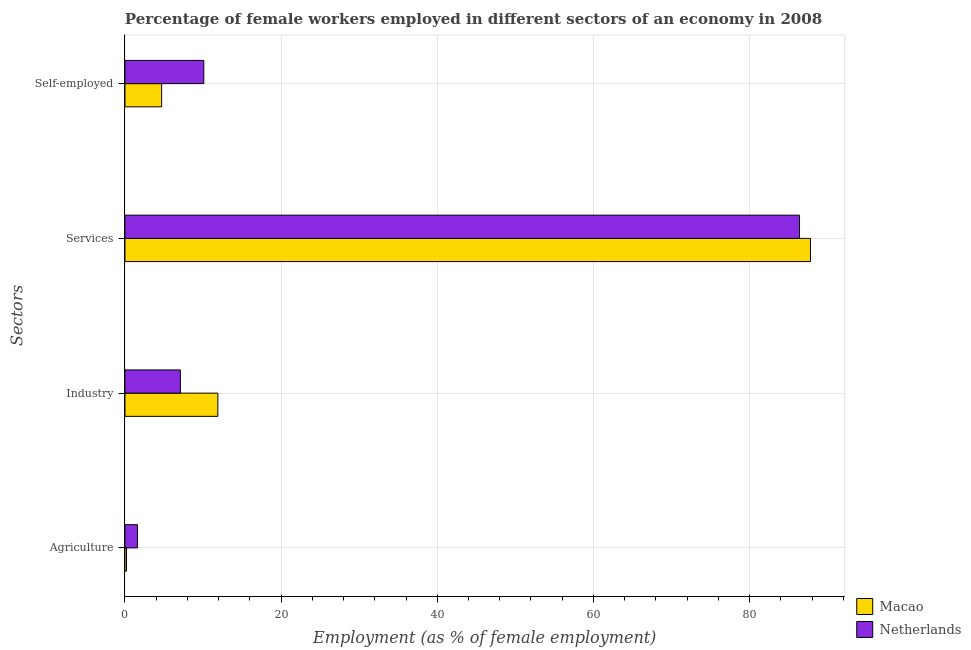Are the number of bars per tick equal to the number of legend labels?
Make the answer very short. Yes. Are the number of bars on each tick of the Y-axis equal?
Keep it short and to the point. Yes. What is the label of the 4th group of bars from the top?
Offer a terse response. Agriculture. What is the percentage of female workers in agriculture in Netherlands?
Ensure brevity in your answer.  1.6. Across all countries, what is the maximum percentage of female workers in agriculture?
Your response must be concise. 1.6. Across all countries, what is the minimum percentage of self employed female workers?
Provide a short and direct response. 4.7. In which country was the percentage of female workers in industry maximum?
Offer a very short reply. Macao. In which country was the percentage of female workers in services minimum?
Give a very brief answer. Netherlands. What is the total percentage of female workers in services in the graph?
Your response must be concise. 174.2. What is the difference between the percentage of female workers in industry in Netherlands and that in Macao?
Offer a terse response. -4.8. What is the difference between the percentage of female workers in agriculture in Macao and the percentage of self employed female workers in Netherlands?
Keep it short and to the point. -9.9. What is the average percentage of female workers in agriculture per country?
Give a very brief answer. 0.9. What is the difference between the percentage of self employed female workers and percentage of female workers in agriculture in Macao?
Make the answer very short. 4.5. What is the ratio of the percentage of self employed female workers in Netherlands to that in Macao?
Provide a short and direct response. 2.15. Is the percentage of female workers in services in Netherlands less than that in Macao?
Your answer should be very brief. Yes. Is the difference between the percentage of female workers in services in Macao and Netherlands greater than the difference between the percentage of female workers in industry in Macao and Netherlands?
Give a very brief answer. No. What is the difference between the highest and the second highest percentage of female workers in services?
Provide a short and direct response. 1.4. What is the difference between the highest and the lowest percentage of female workers in services?
Provide a succinct answer. 1.4. Is it the case that in every country, the sum of the percentage of female workers in services and percentage of female workers in industry is greater than the sum of percentage of self employed female workers and percentage of female workers in agriculture?
Your answer should be very brief. Yes. Is it the case that in every country, the sum of the percentage of female workers in agriculture and percentage of female workers in industry is greater than the percentage of female workers in services?
Provide a succinct answer. No. How many bars are there?
Offer a very short reply. 8. Are all the bars in the graph horizontal?
Give a very brief answer. Yes. How many countries are there in the graph?
Provide a short and direct response. 2. Does the graph contain any zero values?
Your answer should be very brief. No. How many legend labels are there?
Your answer should be compact. 2. What is the title of the graph?
Your answer should be very brief. Percentage of female workers employed in different sectors of an economy in 2008. What is the label or title of the X-axis?
Your response must be concise. Employment (as % of female employment). What is the label or title of the Y-axis?
Your answer should be very brief. Sectors. What is the Employment (as % of female employment) of Macao in Agriculture?
Your answer should be compact. 0.2. What is the Employment (as % of female employment) in Netherlands in Agriculture?
Ensure brevity in your answer.  1.6. What is the Employment (as % of female employment) in Macao in Industry?
Your response must be concise. 11.9. What is the Employment (as % of female employment) in Netherlands in Industry?
Ensure brevity in your answer.  7.1. What is the Employment (as % of female employment) in Macao in Services?
Provide a succinct answer. 87.8. What is the Employment (as % of female employment) in Netherlands in Services?
Your response must be concise. 86.4. What is the Employment (as % of female employment) in Macao in Self-employed?
Keep it short and to the point. 4.7. What is the Employment (as % of female employment) of Netherlands in Self-employed?
Make the answer very short. 10.1. Across all Sectors, what is the maximum Employment (as % of female employment) in Macao?
Make the answer very short. 87.8. Across all Sectors, what is the maximum Employment (as % of female employment) of Netherlands?
Provide a succinct answer. 86.4. Across all Sectors, what is the minimum Employment (as % of female employment) in Macao?
Offer a very short reply. 0.2. Across all Sectors, what is the minimum Employment (as % of female employment) in Netherlands?
Offer a terse response. 1.6. What is the total Employment (as % of female employment) in Macao in the graph?
Your answer should be compact. 104.6. What is the total Employment (as % of female employment) in Netherlands in the graph?
Offer a very short reply. 105.2. What is the difference between the Employment (as % of female employment) of Macao in Agriculture and that in Industry?
Provide a short and direct response. -11.7. What is the difference between the Employment (as % of female employment) of Netherlands in Agriculture and that in Industry?
Provide a short and direct response. -5.5. What is the difference between the Employment (as % of female employment) of Macao in Agriculture and that in Services?
Your answer should be very brief. -87.6. What is the difference between the Employment (as % of female employment) of Netherlands in Agriculture and that in Services?
Keep it short and to the point. -84.8. What is the difference between the Employment (as % of female employment) of Macao in Agriculture and that in Self-employed?
Keep it short and to the point. -4.5. What is the difference between the Employment (as % of female employment) in Netherlands in Agriculture and that in Self-employed?
Keep it short and to the point. -8.5. What is the difference between the Employment (as % of female employment) in Macao in Industry and that in Services?
Offer a terse response. -75.9. What is the difference between the Employment (as % of female employment) of Netherlands in Industry and that in Services?
Provide a short and direct response. -79.3. What is the difference between the Employment (as % of female employment) of Macao in Industry and that in Self-employed?
Provide a succinct answer. 7.2. What is the difference between the Employment (as % of female employment) in Netherlands in Industry and that in Self-employed?
Your answer should be very brief. -3. What is the difference between the Employment (as % of female employment) of Macao in Services and that in Self-employed?
Keep it short and to the point. 83.1. What is the difference between the Employment (as % of female employment) of Netherlands in Services and that in Self-employed?
Offer a very short reply. 76.3. What is the difference between the Employment (as % of female employment) of Macao in Agriculture and the Employment (as % of female employment) of Netherlands in Industry?
Keep it short and to the point. -6.9. What is the difference between the Employment (as % of female employment) of Macao in Agriculture and the Employment (as % of female employment) of Netherlands in Services?
Make the answer very short. -86.2. What is the difference between the Employment (as % of female employment) of Macao in Agriculture and the Employment (as % of female employment) of Netherlands in Self-employed?
Offer a very short reply. -9.9. What is the difference between the Employment (as % of female employment) of Macao in Industry and the Employment (as % of female employment) of Netherlands in Services?
Your response must be concise. -74.5. What is the difference between the Employment (as % of female employment) of Macao in Services and the Employment (as % of female employment) of Netherlands in Self-employed?
Offer a very short reply. 77.7. What is the average Employment (as % of female employment) of Macao per Sectors?
Offer a terse response. 26.15. What is the average Employment (as % of female employment) of Netherlands per Sectors?
Offer a terse response. 26.3. What is the difference between the Employment (as % of female employment) in Macao and Employment (as % of female employment) in Netherlands in Industry?
Keep it short and to the point. 4.8. What is the difference between the Employment (as % of female employment) of Macao and Employment (as % of female employment) of Netherlands in Self-employed?
Give a very brief answer. -5.4. What is the ratio of the Employment (as % of female employment) in Macao in Agriculture to that in Industry?
Give a very brief answer. 0.02. What is the ratio of the Employment (as % of female employment) in Netherlands in Agriculture to that in Industry?
Make the answer very short. 0.23. What is the ratio of the Employment (as % of female employment) in Macao in Agriculture to that in Services?
Ensure brevity in your answer.  0. What is the ratio of the Employment (as % of female employment) in Netherlands in Agriculture to that in Services?
Keep it short and to the point. 0.02. What is the ratio of the Employment (as % of female employment) in Macao in Agriculture to that in Self-employed?
Keep it short and to the point. 0.04. What is the ratio of the Employment (as % of female employment) of Netherlands in Agriculture to that in Self-employed?
Your answer should be compact. 0.16. What is the ratio of the Employment (as % of female employment) of Macao in Industry to that in Services?
Your answer should be very brief. 0.14. What is the ratio of the Employment (as % of female employment) in Netherlands in Industry to that in Services?
Give a very brief answer. 0.08. What is the ratio of the Employment (as % of female employment) in Macao in Industry to that in Self-employed?
Your answer should be very brief. 2.53. What is the ratio of the Employment (as % of female employment) in Netherlands in Industry to that in Self-employed?
Your answer should be compact. 0.7. What is the ratio of the Employment (as % of female employment) of Macao in Services to that in Self-employed?
Ensure brevity in your answer.  18.68. What is the ratio of the Employment (as % of female employment) of Netherlands in Services to that in Self-employed?
Provide a short and direct response. 8.55. What is the difference between the highest and the second highest Employment (as % of female employment) in Macao?
Provide a succinct answer. 75.9. What is the difference between the highest and the second highest Employment (as % of female employment) of Netherlands?
Your response must be concise. 76.3. What is the difference between the highest and the lowest Employment (as % of female employment) of Macao?
Make the answer very short. 87.6. What is the difference between the highest and the lowest Employment (as % of female employment) in Netherlands?
Offer a very short reply. 84.8. 